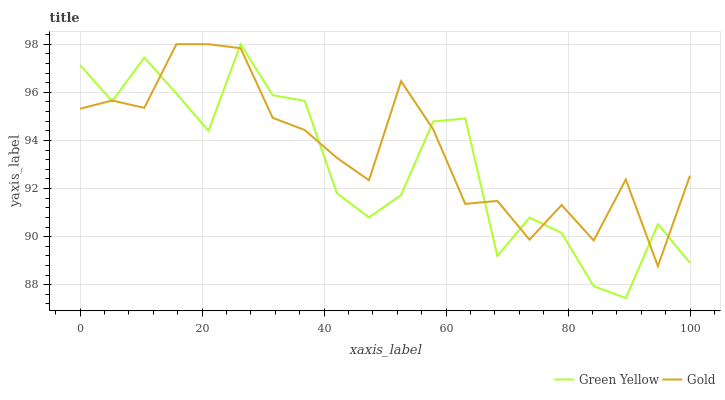Does Green Yellow have the minimum area under the curve?
Answer yes or no. Yes. Does Gold have the maximum area under the curve?
Answer yes or no. Yes. Does Gold have the minimum area under the curve?
Answer yes or no. No. Is Gold the smoothest?
Answer yes or no. Yes. Is Green Yellow the roughest?
Answer yes or no. Yes. Is Gold the roughest?
Answer yes or no. No. Does Gold have the lowest value?
Answer yes or no. No. Does Gold have the highest value?
Answer yes or no. Yes. Does Green Yellow intersect Gold?
Answer yes or no. Yes. Is Green Yellow less than Gold?
Answer yes or no. No. Is Green Yellow greater than Gold?
Answer yes or no. No. 